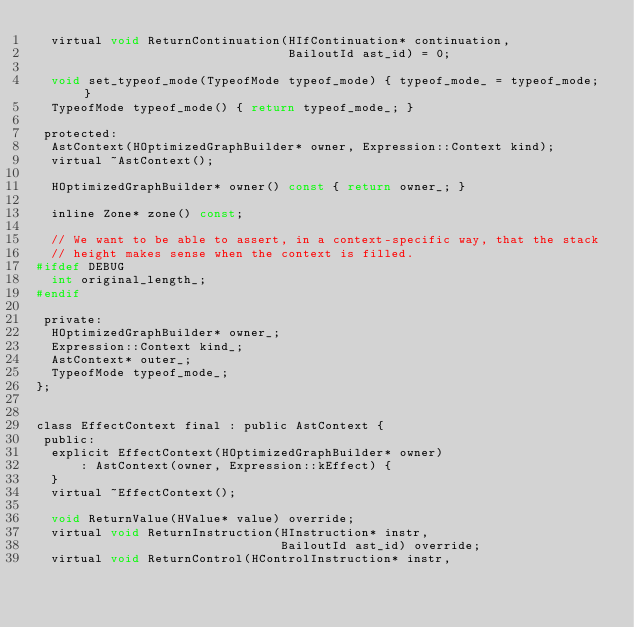<code> <loc_0><loc_0><loc_500><loc_500><_C_>  virtual void ReturnContinuation(HIfContinuation* continuation,
                                  BailoutId ast_id) = 0;

  void set_typeof_mode(TypeofMode typeof_mode) { typeof_mode_ = typeof_mode; }
  TypeofMode typeof_mode() { return typeof_mode_; }

 protected:
  AstContext(HOptimizedGraphBuilder* owner, Expression::Context kind);
  virtual ~AstContext();

  HOptimizedGraphBuilder* owner() const { return owner_; }

  inline Zone* zone() const;

  // We want to be able to assert, in a context-specific way, that the stack
  // height makes sense when the context is filled.
#ifdef DEBUG
  int original_length_;
#endif

 private:
  HOptimizedGraphBuilder* owner_;
  Expression::Context kind_;
  AstContext* outer_;
  TypeofMode typeof_mode_;
};


class EffectContext final : public AstContext {
 public:
  explicit EffectContext(HOptimizedGraphBuilder* owner)
      : AstContext(owner, Expression::kEffect) {
  }
  virtual ~EffectContext();

  void ReturnValue(HValue* value) override;
  virtual void ReturnInstruction(HInstruction* instr,
                                 BailoutId ast_id) override;
  virtual void ReturnControl(HControlInstruction* instr,</code> 